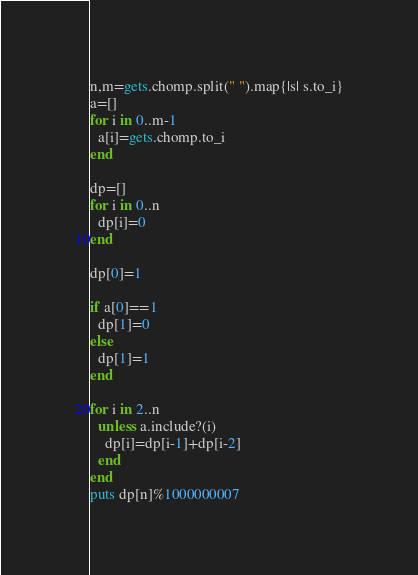Convert code to text. <code><loc_0><loc_0><loc_500><loc_500><_Ruby_>n,m=gets.chomp.split(" ").map{|s| s.to_i}
a=[]
for i in 0..m-1
  a[i]=gets.chomp.to_i
end

dp=[]
for i in 0..n
  dp[i]=0
end

dp[0]=1

if a[0]==1
  dp[1]=0
else
  dp[1]=1
end

for i in 2..n
  unless a.include?(i)
    dp[i]=dp[i-1]+dp[i-2]
  end
end
puts dp[n]%1000000007
</code> 